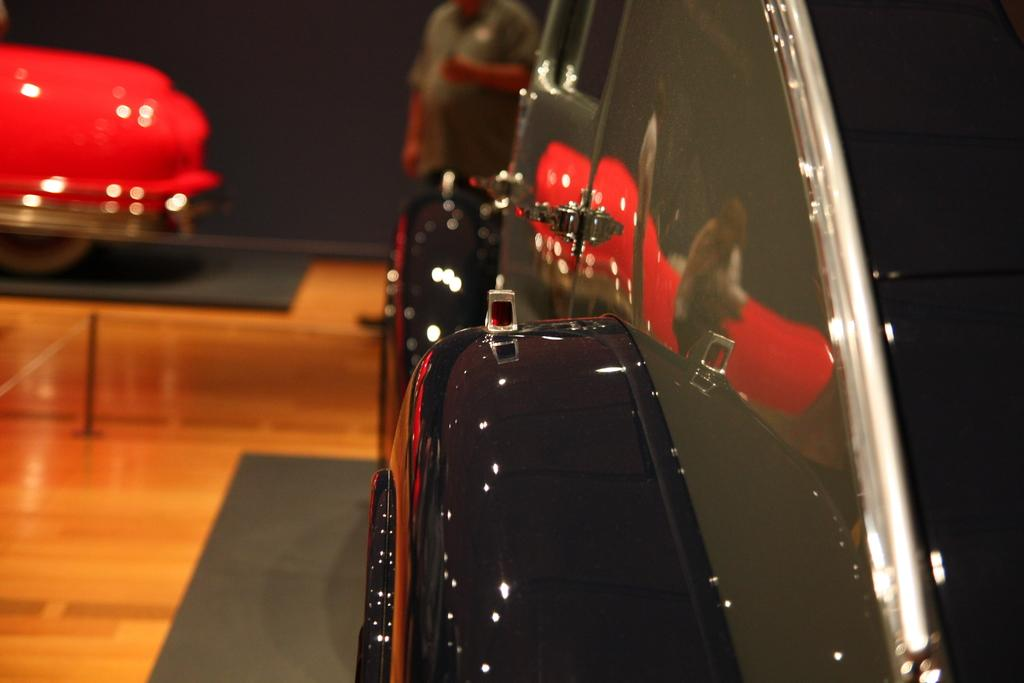What types of vehicles are in the image? There are vehicles in the image, but the specific types are not mentioned. What is on the floor in the image? There are carpets on the floor in the image. What can be seen on the left side of the image? There is a pole on the left side of the image. Can you describe the man in the background of the image? A man is standing in the background of the image. How does the honey drip from the icicle in the image? There is no icicle or honey present in the image. What type of shock can be seen on the man's face in the image? There is no indication of a shock or any facial expression on the man's face in the image. 